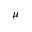Convert formula to latex. <formula><loc_0><loc_0><loc_500><loc_500>\mu</formula> 